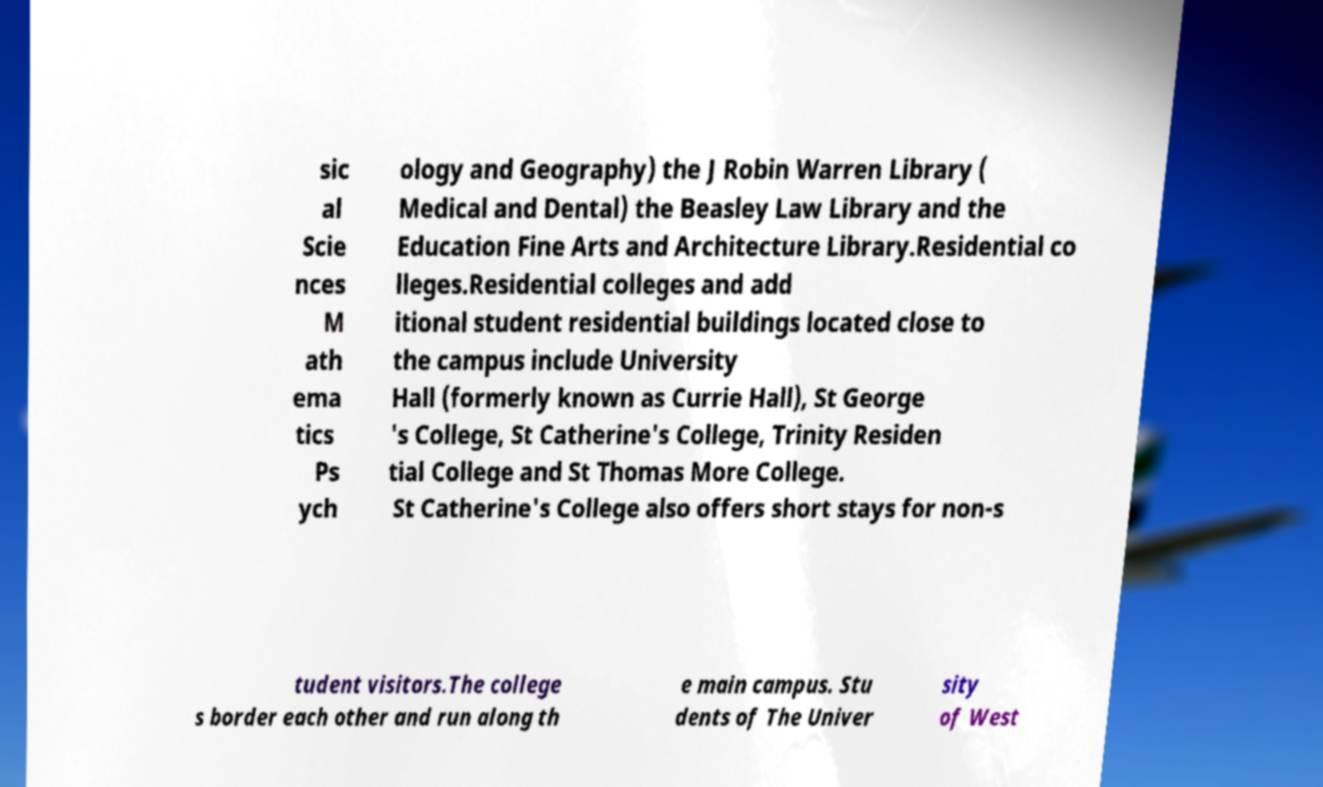Please read and relay the text visible in this image. What does it say? sic al Scie nces M ath ema tics Ps ych ology and Geography) the J Robin Warren Library ( Medical and Dental) the Beasley Law Library and the Education Fine Arts and Architecture Library.Residential co lleges.Residential colleges and add itional student residential buildings located close to the campus include University Hall (formerly known as Currie Hall), St George 's College, St Catherine's College, Trinity Residen tial College and St Thomas More College. St Catherine's College also offers short stays for non-s tudent visitors.The college s border each other and run along th e main campus. Stu dents of The Univer sity of West 